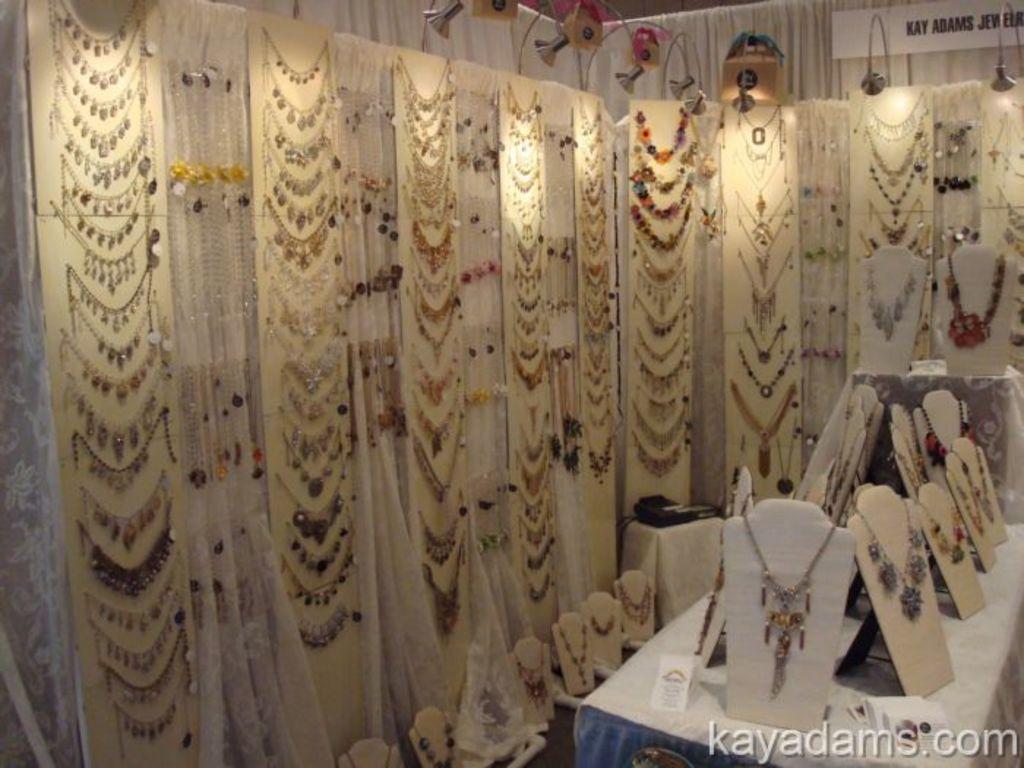In one or two sentences, can you explain what this image depicts? In this image we can see ornaments, a table, beside that we can see text written on the board, And we can see curtains, at the bottom we can see the watermark. 